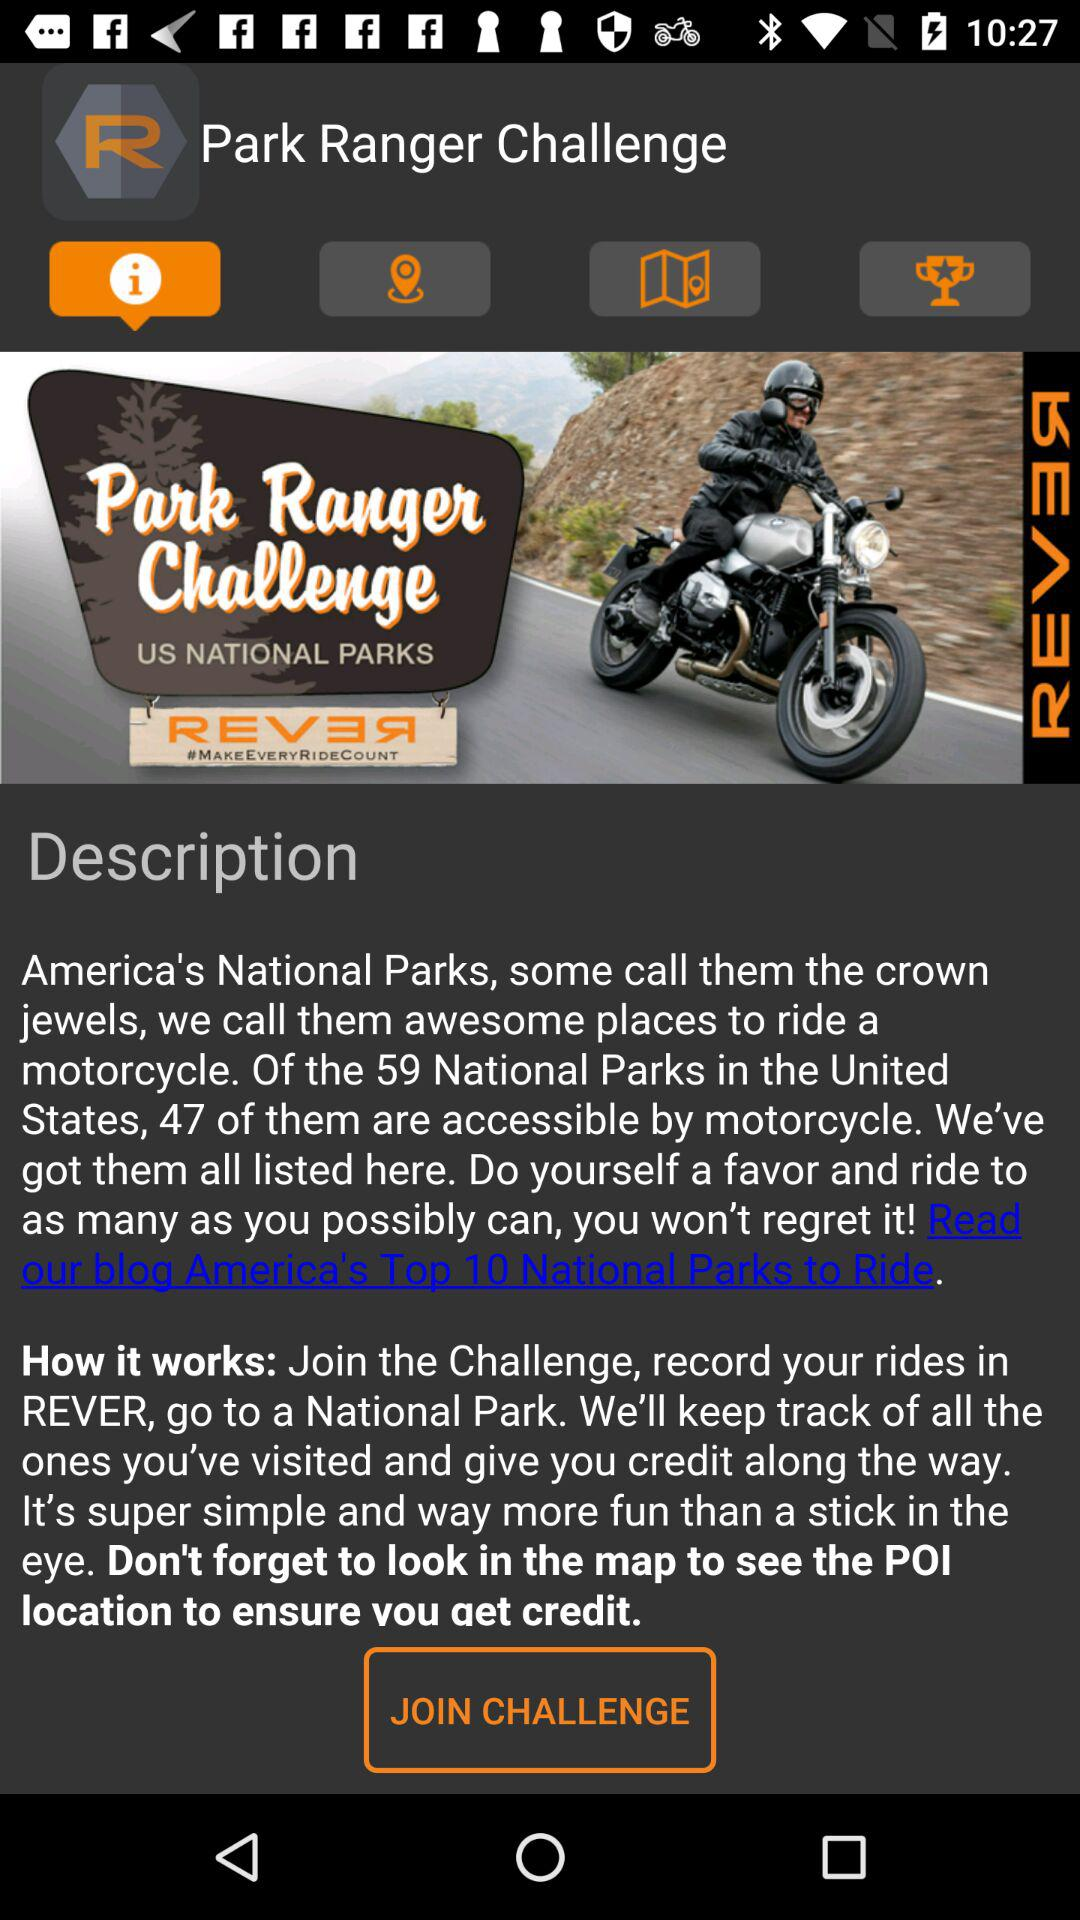What is the application name? The application name is "REVER - Motorcycle GPS & Rides". 